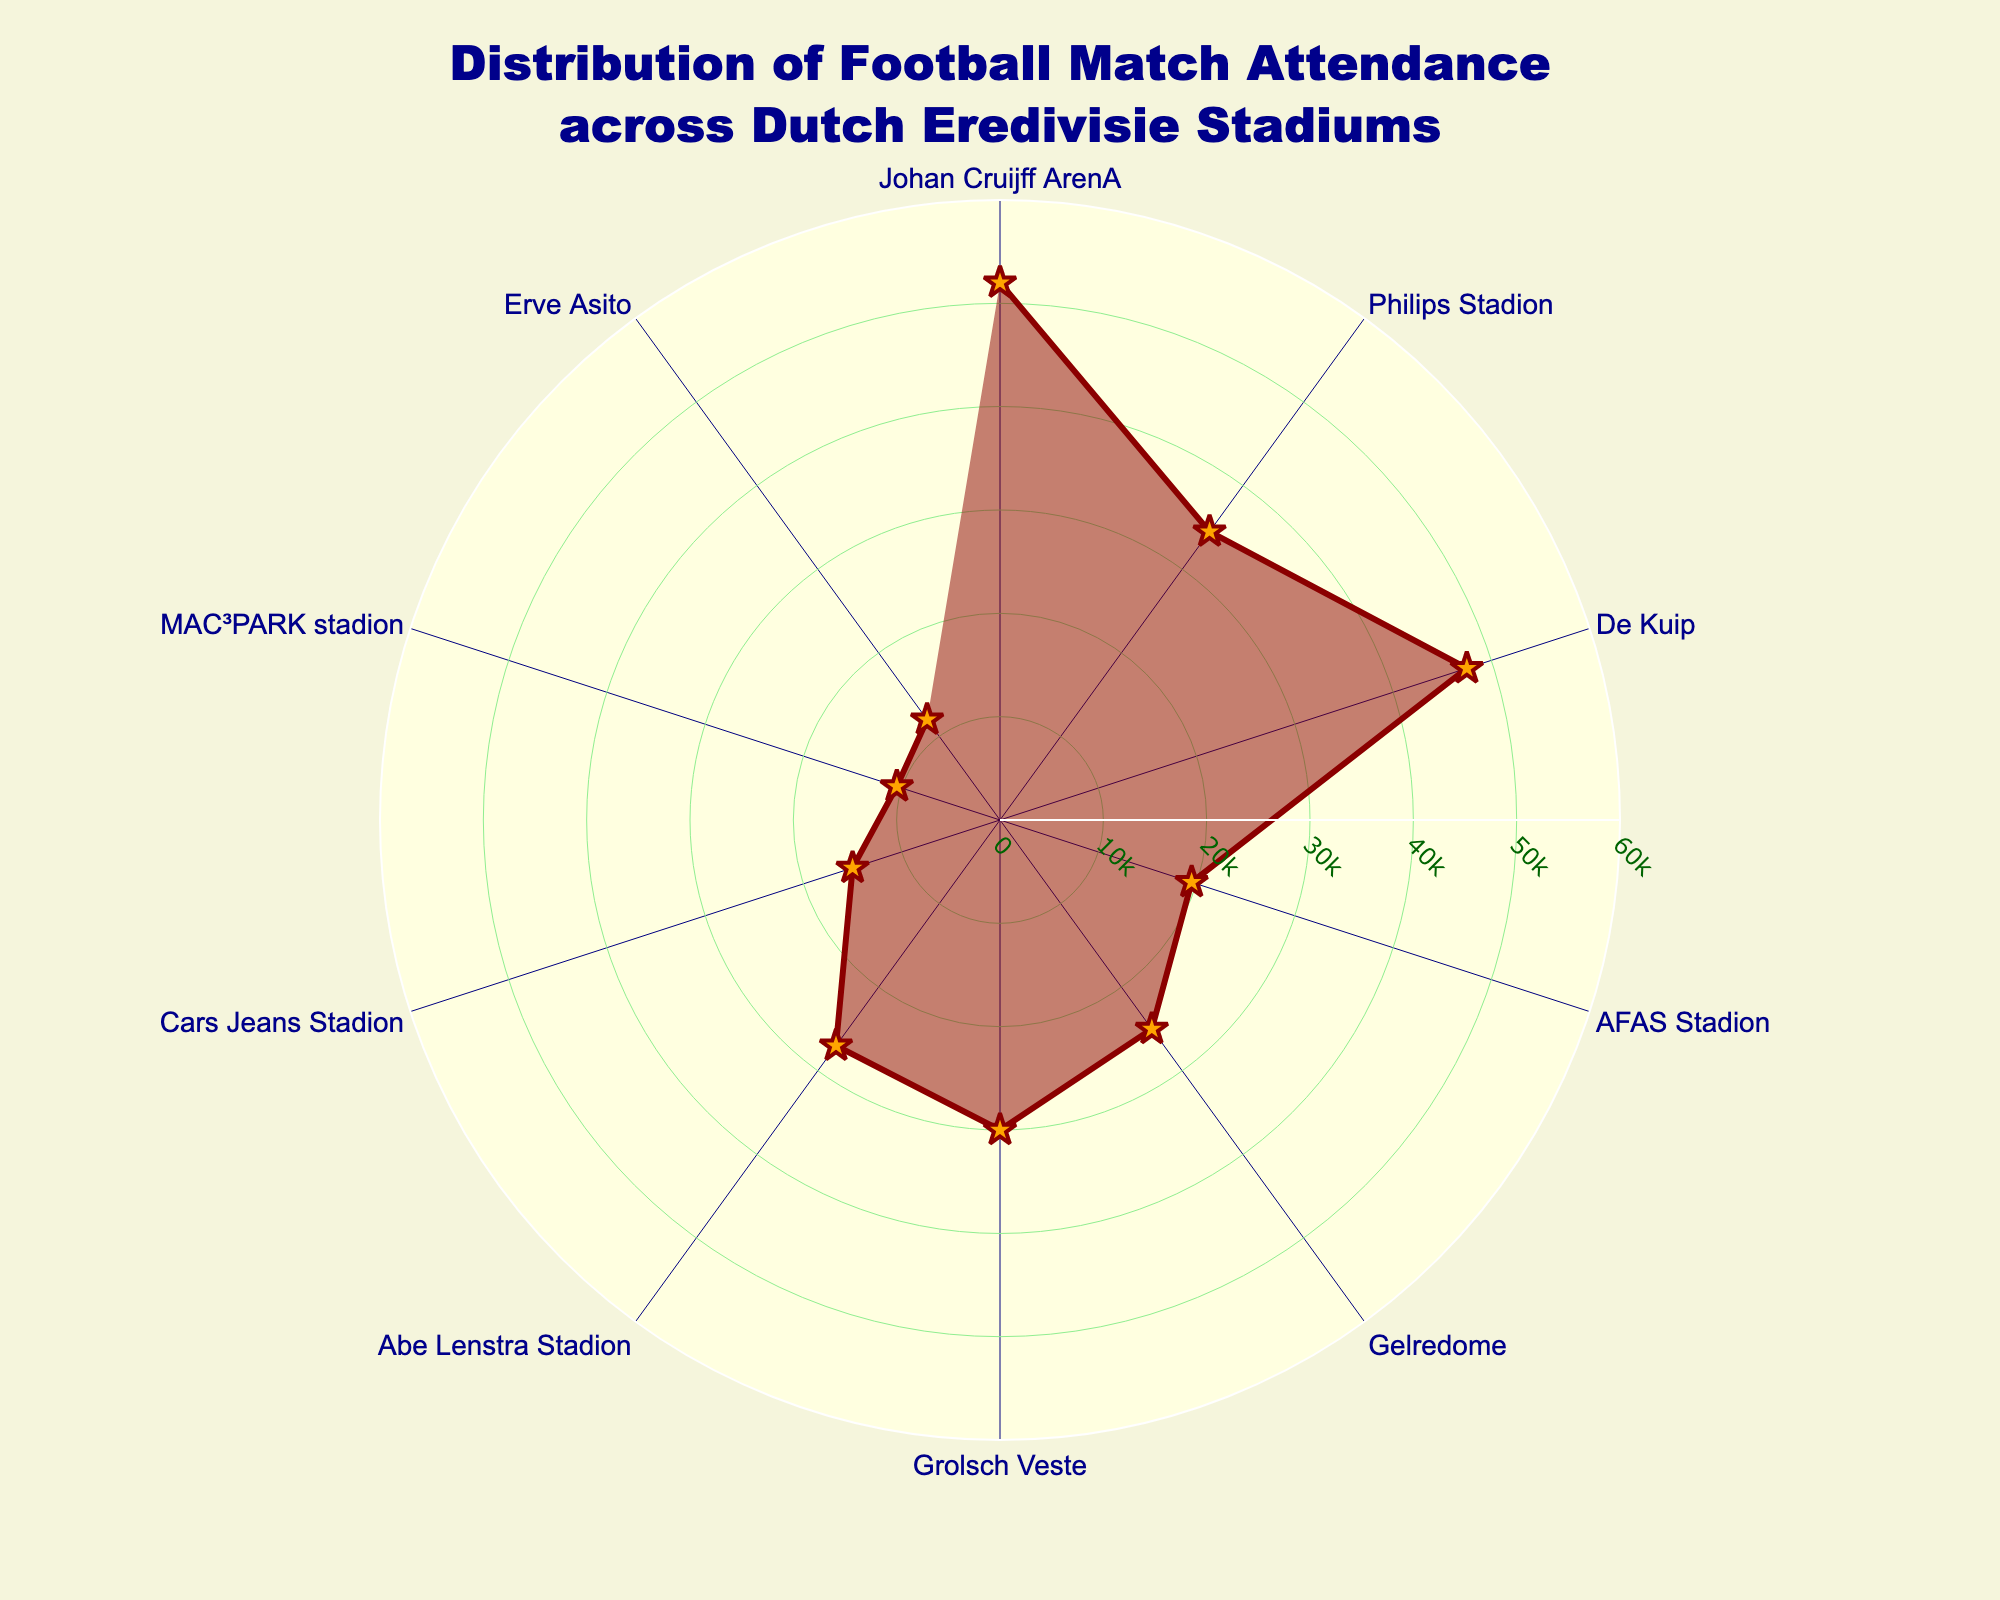What's the title of the plot? The title is located at the top center of the plot, generally using a larger font size and different color for emphasis. It provides the main description of what the plot represents.
Answer: Distribution of Football Match Attendance across Dutch Eredivisie Stadiums Which stadium has the highest attendance? By comparing the radial lengths for each stadium shown on the polar chart, the one with the longest radial length represents the highest attendance.
Answer: Johan Cruijff ArenA Which stadium has the lowest attendance? To find the lowest attendance, look for the shortest radial length in the polar chart. This indicates which stadium has the least number of attendees.
Answer: MAC³PARK stadion What is the average attendance across all the listed stadiums? Add up all the attendance numbers and divide by the number of stadiums. Step-by-step: (52000 + 34500 + 47500 + 19500 + 25000 + 30000 + 27000 + 15000 + 10500 + 12000) / 10 = 29800.
Answer: 29800 Compare the attendance between Johan Cruijff ArenA and Philips Stadion. Which one is higher, and by how much? By moving radially from the center, the longer distance belongs to Johan Cruijff ArenA. Steps: 52000 (Johan Cruijff ArenA) - 34500 (Philips Stadion) = 17500.
Answer: Johan Cruijff ArenA by 17500 What is the attendance range depicted in this chart? The range is the difference between the highest and lowest attendance values. Steps: 52000 (highest) - 10500 (lowest) = 41500.
Answer: 41500 Which stadiums have an attendance higher than 30,000? Identify which radial lengths exceed the 30,000 mark. By visualizing, these stadiums are Johan Cruijff ArenA, Philips Stadion, De Kuip, and Grolsch Veste.
Answer: Johan Cruijff ArenA, Philips Stadion, De Kuip, Grolsch Veste How many stadiums have an attendance of less than 20,000? Count the radial lines that are shorter than the 20,000 mark.
Answer: 3 (AFAS Stadion, Cars Jeans Stadion, MAC³PARK stadion, Erve Asito) What's the difference in attendance between De Kuip and Gelredome? Calculate the absolute difference between the two radial lengths. Steps: 47500 (De Kuip) - 25000 (Gelredome) = 22500.
Answer: 22500 What visual characteristics are used to represent the data points in the chart? The polar chart employs radial lines for attendance, labels around the circle for stadium names, and a colored (orange) fill with markers shaped as stars. Additional stylizing includes darkred lines and a lightyellow background.
Answer: Radial lines, circle labels, orange fill, star markers 